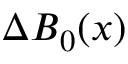Convert formula to latex. <formula><loc_0><loc_0><loc_500><loc_500>\Delta B _ { 0 } ( x )</formula> 